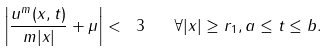<formula> <loc_0><loc_0><loc_500><loc_500>\left | \frac { u ^ { m } ( x , t ) } { m | x | } + \mu \right | < \ 3 \quad \forall | x | \geq r _ { 1 } , a \leq t \leq b .</formula> 